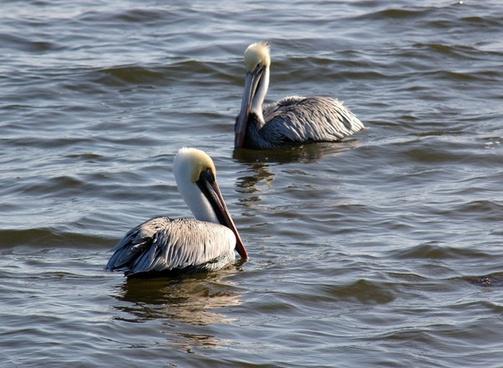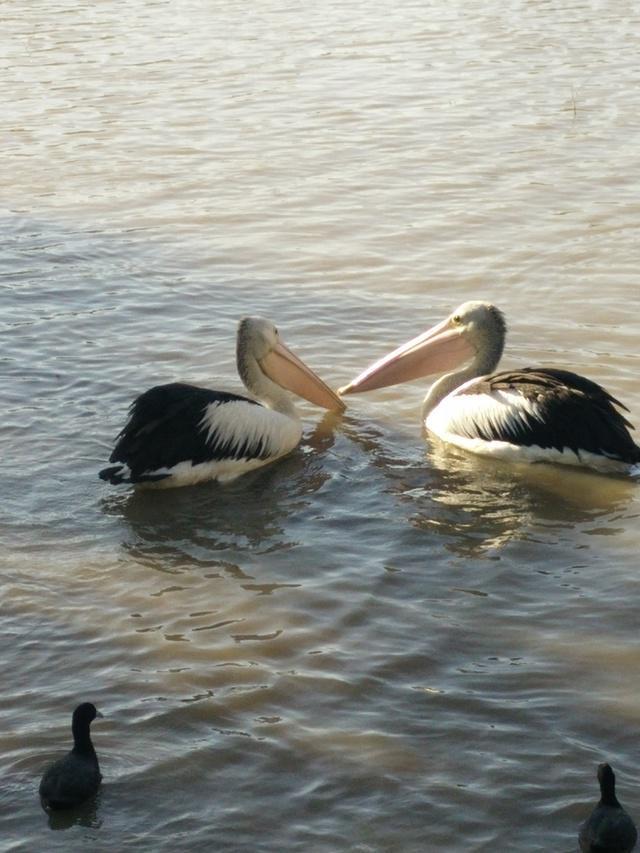The first image is the image on the left, the second image is the image on the right. Examine the images to the left and right. Is the description "There is no more than two birds in the left image." accurate? Answer yes or no. Yes. The first image is the image on the left, the second image is the image on the right. Examine the images to the left and right. Is the description "All pelicans are on the water, one image contains exactly two pelicans, and each image contains no more than three pelicans." accurate? Answer yes or no. Yes. 